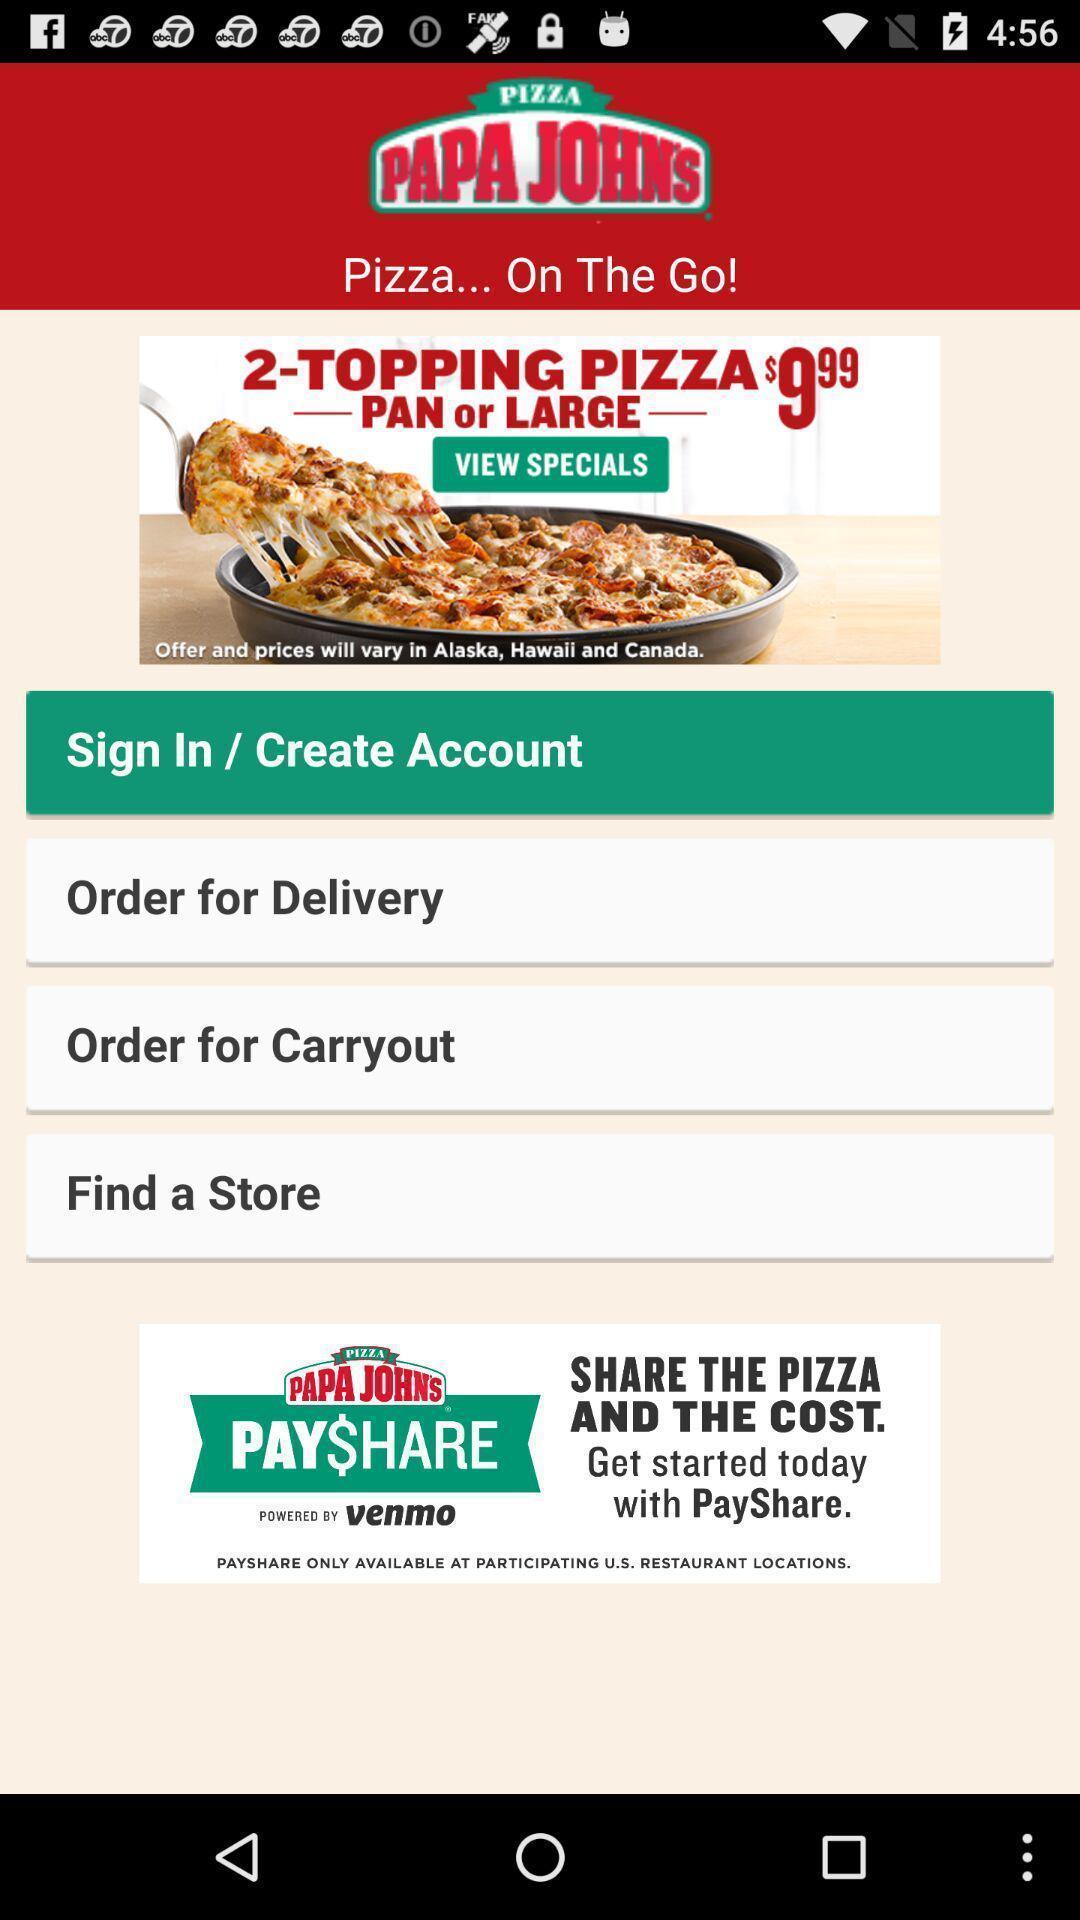What details can you identify in this image? Sign in page. 